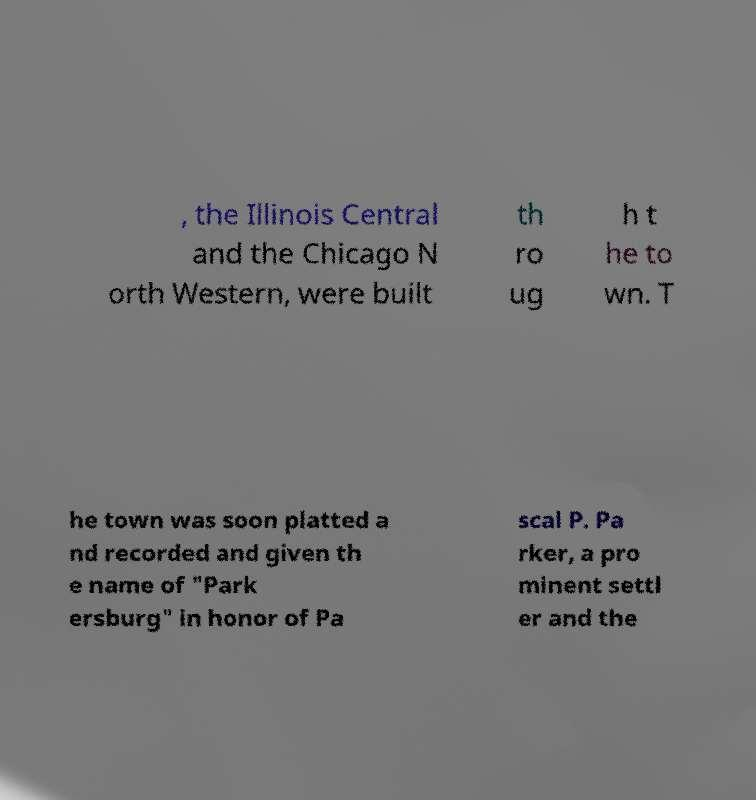Can you accurately transcribe the text from the provided image for me? , the Illinois Central and the Chicago N orth Western, were built th ro ug h t he to wn. T he town was soon platted a nd recorded and given th e name of "Park ersburg" in honor of Pa scal P. Pa rker, a pro minent settl er and the 